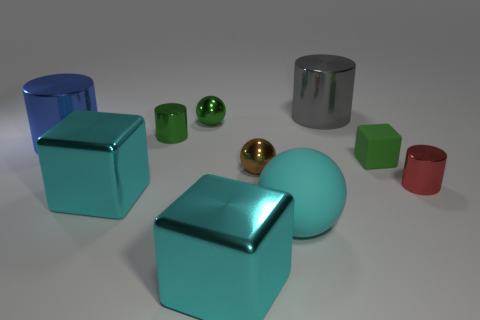What shape is the tiny thing that is to the right of the brown shiny ball and to the left of the red shiny cylinder?
Your answer should be compact. Cube. Is the green cylinder the same size as the brown metal sphere?
Your response must be concise. Yes. Is there another large red sphere that has the same material as the large sphere?
Keep it short and to the point. No. What size is the ball that is the same color as the small rubber thing?
Provide a short and direct response. Small. How many large objects are in front of the tiny red metallic cylinder and behind the green cylinder?
Offer a very short reply. 0. There is a large cyan block that is right of the tiny green sphere; what material is it?
Ensure brevity in your answer.  Metal. How many small metal cylinders have the same color as the matte block?
Offer a very short reply. 1. The cyan ball that is made of the same material as the tiny green block is what size?
Make the answer very short. Large. How many objects are either small green spheres or large yellow blocks?
Give a very brief answer. 1. There is a big metal cylinder right of the big blue cylinder; what is its color?
Your answer should be very brief. Gray. 